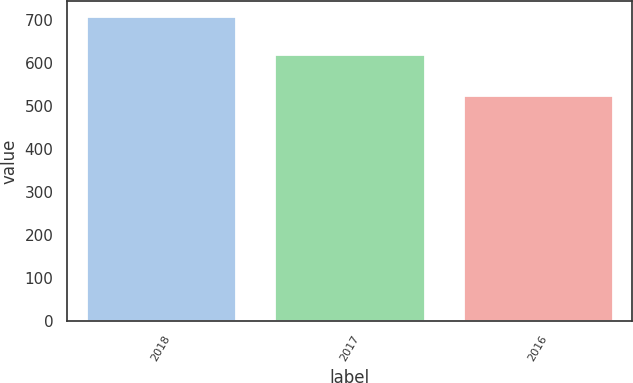Convert chart to OTSL. <chart><loc_0><loc_0><loc_500><loc_500><bar_chart><fcel>2018<fcel>2017<fcel>2016<nl><fcel>709.5<fcel>621.1<fcel>525.2<nl></chart> 